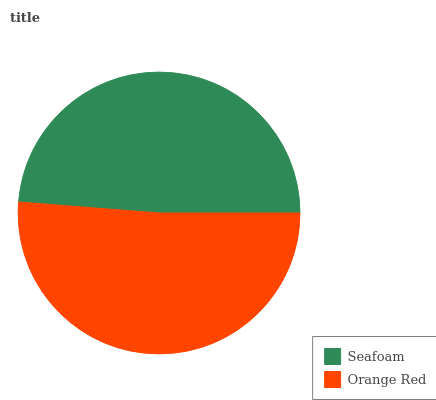Is Seafoam the minimum?
Answer yes or no. Yes. Is Orange Red the maximum?
Answer yes or no. Yes. Is Orange Red the minimum?
Answer yes or no. No. Is Orange Red greater than Seafoam?
Answer yes or no. Yes. Is Seafoam less than Orange Red?
Answer yes or no. Yes. Is Seafoam greater than Orange Red?
Answer yes or no. No. Is Orange Red less than Seafoam?
Answer yes or no. No. Is Orange Red the high median?
Answer yes or no. Yes. Is Seafoam the low median?
Answer yes or no. Yes. Is Seafoam the high median?
Answer yes or no. No. Is Orange Red the low median?
Answer yes or no. No. 